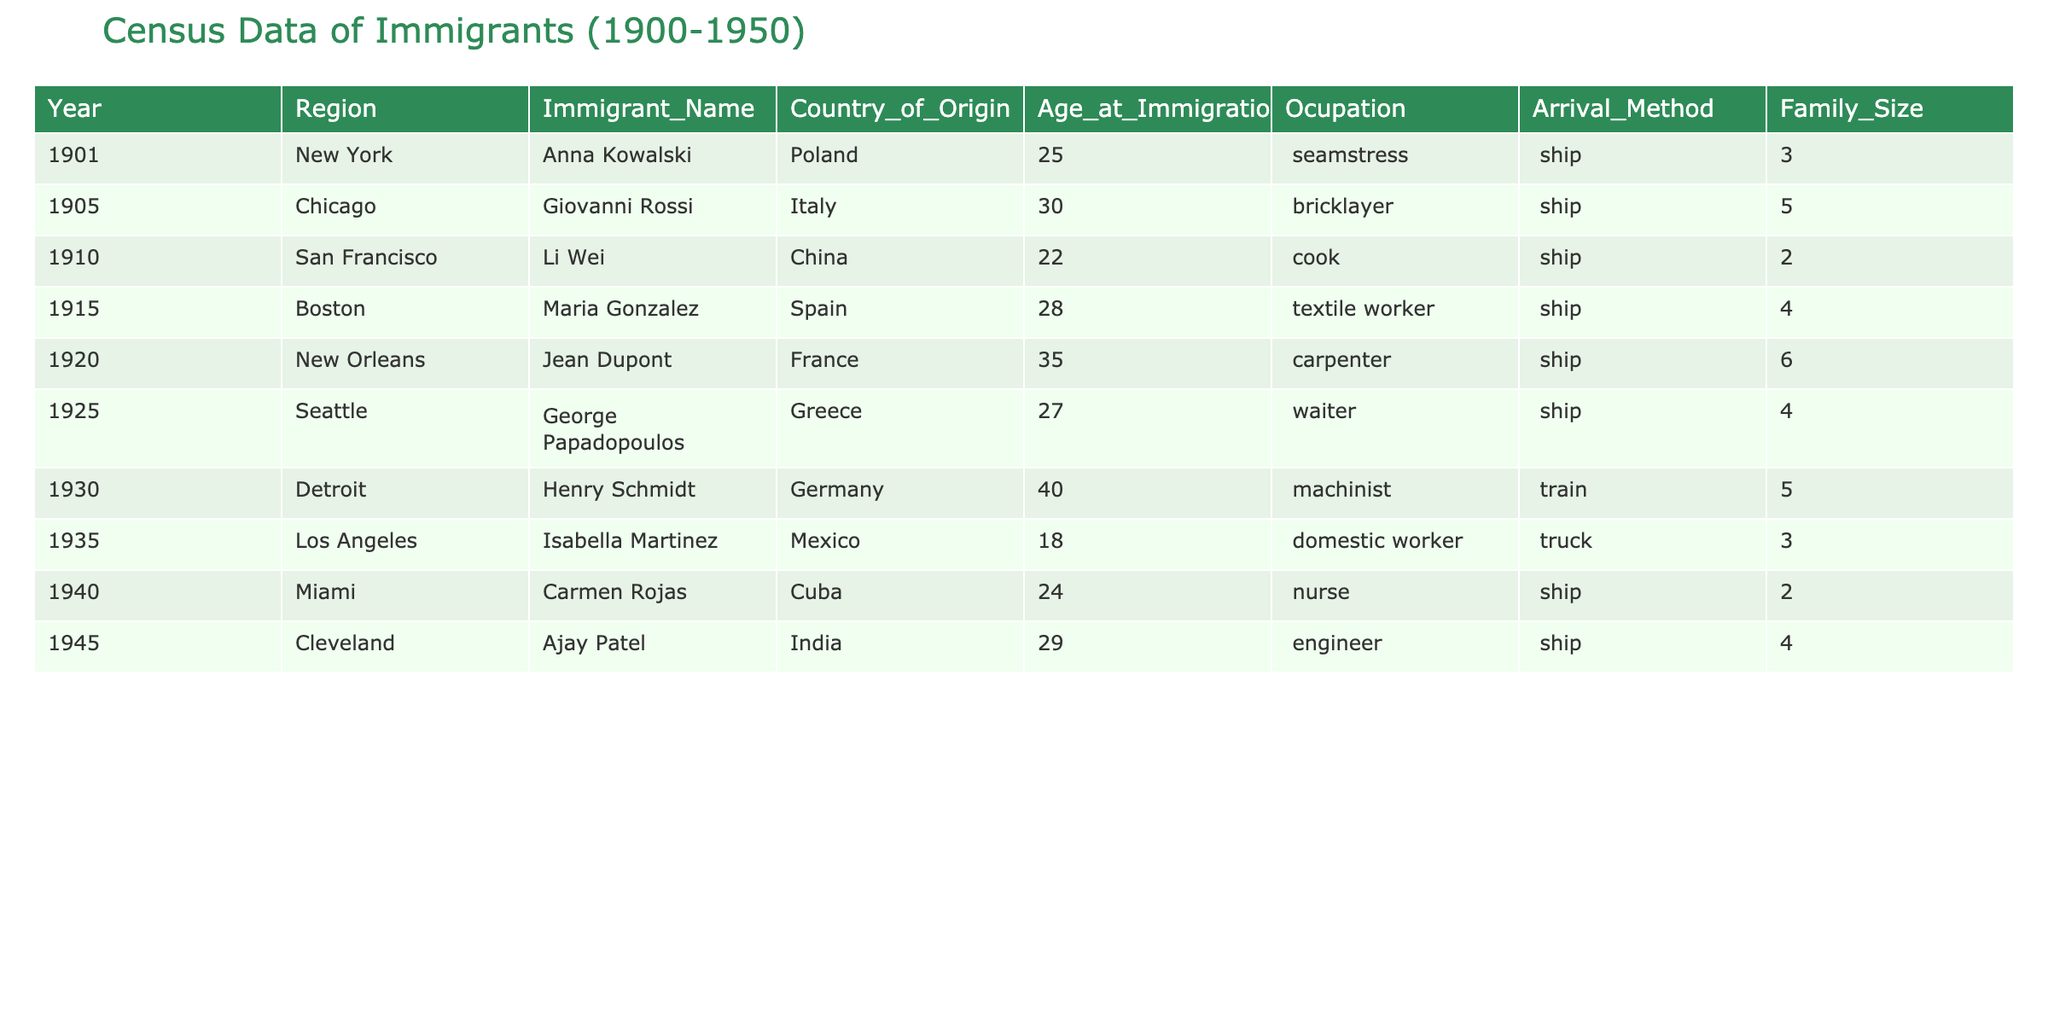What year did Anna Kowalski immigrate? The table lists Anna Kowalski's immigration year in the first row under the Year column. It shows that she immigrated in 1901.
Answer: 1901 Which occupation did Giovan Rossi have? In the second row of the table, the Occupation column corresponds to Giovan Rossi, showing that he was a bricklayer.
Answer: Bricklayer How many immigrants came from China? Referring to the Country_of_Origin column, Li Wei, the only immigrant listed from China in the table, indicates there is 1 immigrant from China.
Answer: 1 What is the average age at immigration for immigrants from Spain and France? First, we identify Maria Gonzalez's age (28) from Spain and Jean Dupont's age (35) from France. By summing these ages, we get 63, and dividing by 2 gives us an average age of 31.5 for these two immigrants.
Answer: 31.5 Did any immigrant arrive by truck? Reviewing the Arrival_Method column, there is one immigrant, Isabella Martinez, who arrived by truck as shown in her row. Therefore, the answer is yes.
Answer: Yes What is the family size of the immigrant with the highest age at immigration? The highest age is 40 for Henry Schmidt, found in the Age_at_Immigration column (third last row). The Family_Size for this record is 5, indicating that he had a family size of 5.
Answer: 5 Which region had the largest family size among the immigrants listed? To determine this, we look for the maximum number in the Family_Size column, which is 6 for Jean Dupont in New Orleans. Hence, the largest family size is associated with that region.
Answer: New Orleans How many immigrants were under the age of 25? By checking the Age_at_Immigration, we can see that only Isabella Martinez (18) and Carmen Rojas (24) are under 25, giving us a total of 2 immigrants that meet this criterion.
Answer: 2 What was the most common arrival method among the immigrants? Analyzing the Arrival_Method column, 'ship' appears most frequently (7 times), while 'train' appears once and 'truck' appears once, making 'ship' the most common method.
Answer: Ship 